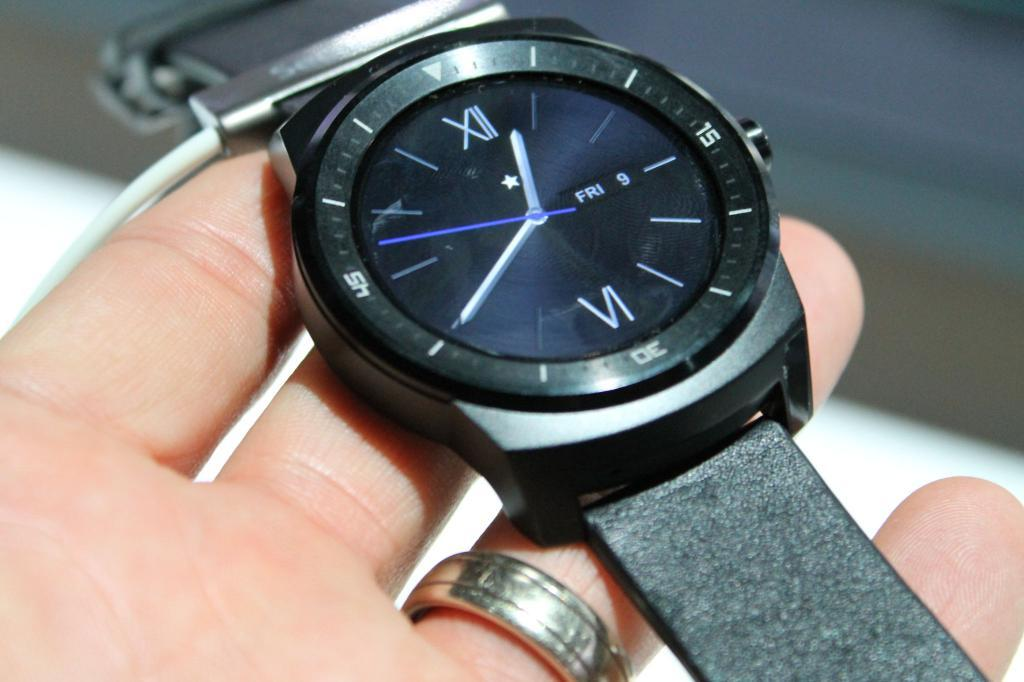<image>
Share a concise interpretation of the image provided. A black watch with roman numerals and the date displayed as Friday 9. 